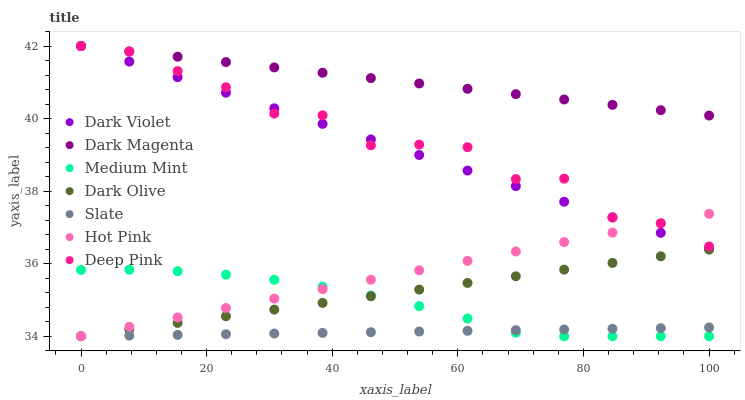Does Slate have the minimum area under the curve?
Answer yes or no. Yes. Does Dark Magenta have the maximum area under the curve?
Answer yes or no. Yes. Does Hot Pink have the minimum area under the curve?
Answer yes or no. No. Does Hot Pink have the maximum area under the curve?
Answer yes or no. No. Is Dark Violet the smoothest?
Answer yes or no. Yes. Is Deep Pink the roughest?
Answer yes or no. Yes. Is Hot Pink the smoothest?
Answer yes or no. No. Is Hot Pink the roughest?
Answer yes or no. No. Does Medium Mint have the lowest value?
Answer yes or no. Yes. Does Dark Magenta have the lowest value?
Answer yes or no. No. Does Deep Pink have the highest value?
Answer yes or no. Yes. Does Hot Pink have the highest value?
Answer yes or no. No. Is Hot Pink less than Dark Magenta?
Answer yes or no. Yes. Is Dark Violet greater than Medium Mint?
Answer yes or no. Yes. Does Dark Magenta intersect Deep Pink?
Answer yes or no. Yes. Is Dark Magenta less than Deep Pink?
Answer yes or no. No. Is Dark Magenta greater than Deep Pink?
Answer yes or no. No. Does Hot Pink intersect Dark Magenta?
Answer yes or no. No. 